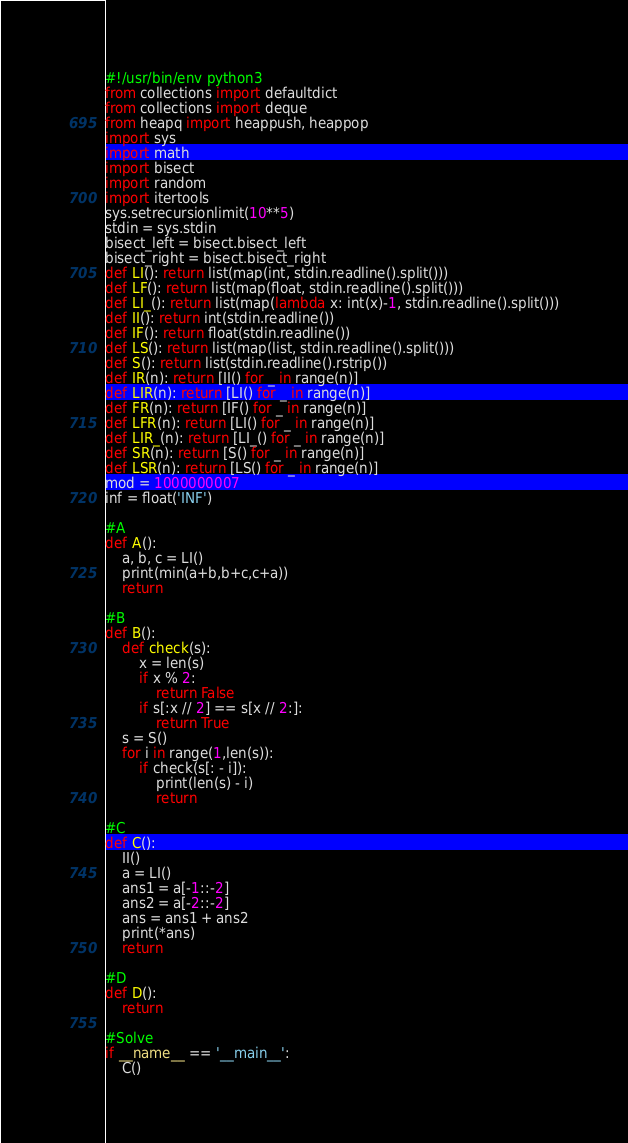<code> <loc_0><loc_0><loc_500><loc_500><_Python_>#!/usr/bin/env python3
from collections import defaultdict
from collections import deque
from heapq import heappush, heappop
import sys
import math
import bisect
import random
import itertools
sys.setrecursionlimit(10**5)
stdin = sys.stdin
bisect_left = bisect.bisect_left
bisect_right = bisect.bisect_right
def LI(): return list(map(int, stdin.readline().split()))
def LF(): return list(map(float, stdin.readline().split()))
def LI_(): return list(map(lambda x: int(x)-1, stdin.readline().split()))
def II(): return int(stdin.readline())
def IF(): return float(stdin.readline())
def LS(): return list(map(list, stdin.readline().split()))
def S(): return list(stdin.readline().rstrip())
def IR(n): return [II() for _ in range(n)]
def LIR(n): return [LI() for _ in range(n)]
def FR(n): return [IF() for _ in range(n)]
def LFR(n): return [LI() for _ in range(n)]
def LIR_(n): return [LI_() for _ in range(n)]
def SR(n): return [S() for _ in range(n)]
def LSR(n): return [LS() for _ in range(n)]
mod = 1000000007
inf = float('INF')

#A
def A():
    a, b, c = LI()
    print(min(a+b,b+c,c+a))
    return

#B
def B():
    def check(s):
        x = len(s)
        if x % 2:
            return False
        if s[:x // 2] == s[x // 2:]:
            return True
    s = S()
    for i in range(1,len(s)):
        if check(s[: - i]):
            print(len(s) - i)
            return

#C
def C():
    II()
    a = LI()
    ans1 = a[-1::-2]
    ans2 = a[-2::-2]
    ans = ans1 + ans2
    print(*ans)
    return

#D
def D():
    return

#Solve
if __name__ == '__main__':
    C()
</code> 